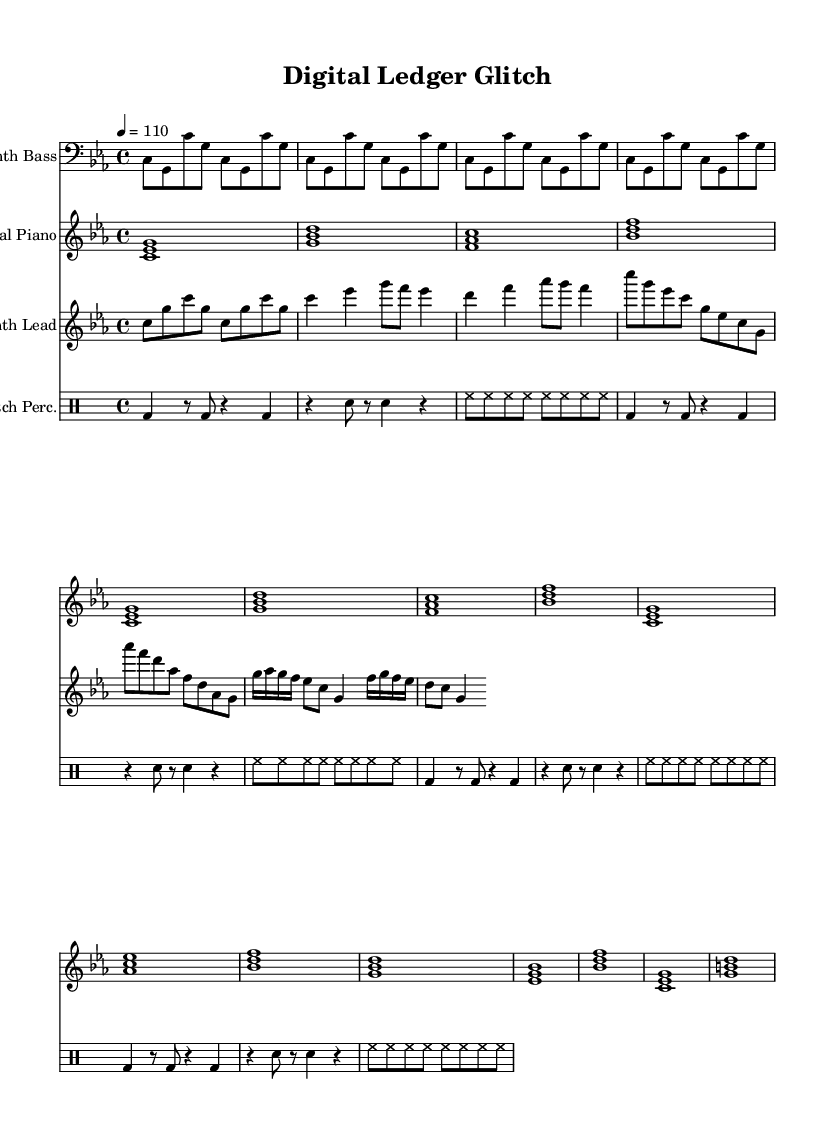What is the key signature of this music? The key signature is C minor, which has three flats (B, E, and A). This can be identified from the key signature indicated before the start of the staff.
Answer: C minor What is the time signature of the piece? The time signature is 4/4, as indicated at the beginning of the score. This means there are four beats in each measure, and a quarter note receives one beat.
Answer: 4/4 What is the tempo marking for this composition? The tempo marking is 110 beats per minute, specified in the tempo line at the beginning, indicating the speed of the music.
Answer: 110 Which instrument plays the synth lead? The synth lead is played by the instrument labeled "Synth Lead" within the score. This is indicated at the start of the respective staff.
Answer: Synth Lead How many measures are there in the synth bass section? The synth bass section consists of 4 measures, as shown by the repeating section that unfolds 4 times. It is clear due to the repetition and structure indicating measure counts.
Answer: 4 In what style does the percussion section primarily sound? The percussion section typically sounds glitchy, as denoted by the term "Glitch Perc." This suggests the use of electronic sounds typical for glitch-hop music.
Answer: Glitch 